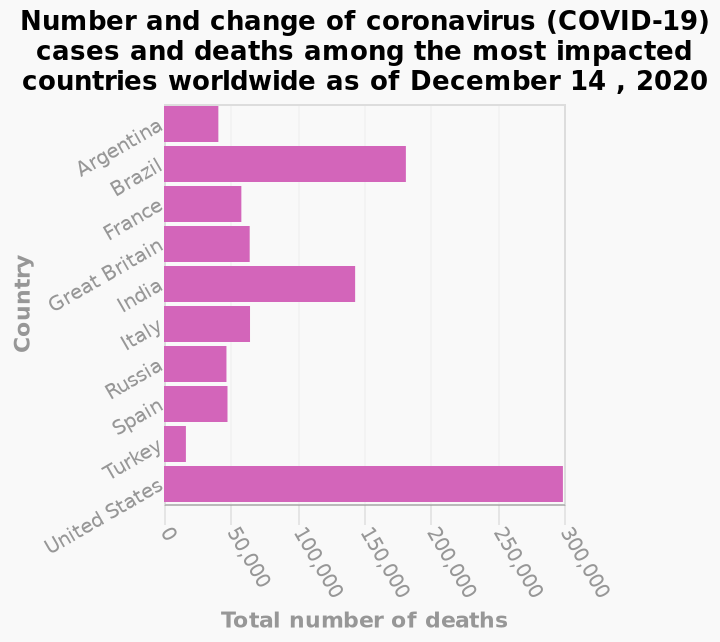<image>
Which country has the most reported cases of COVID-19?  The United States has the most reported cases of COVID-19. Is the number of reported cases in the United States increasing or decreasing?  The description does not provide information about the trend in the number of reported cases in the United States. 